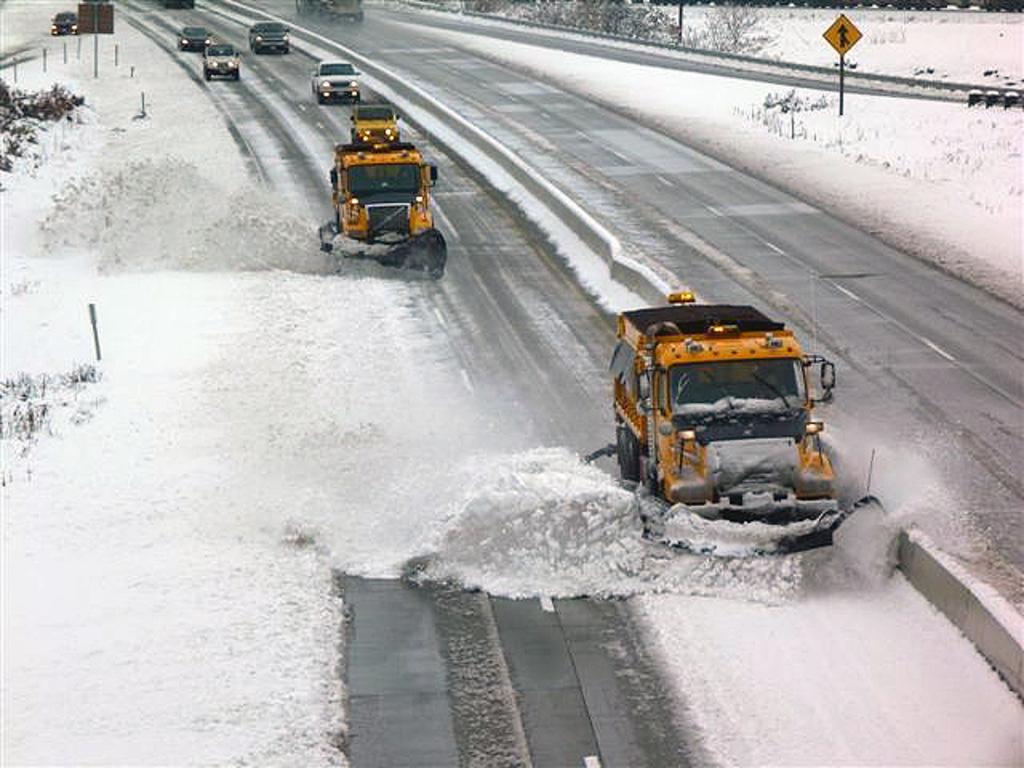Could you give a brief overview of what you see in this image? In this image we can see a few vehicles on the road, there are some trees, poles, water and boards. 